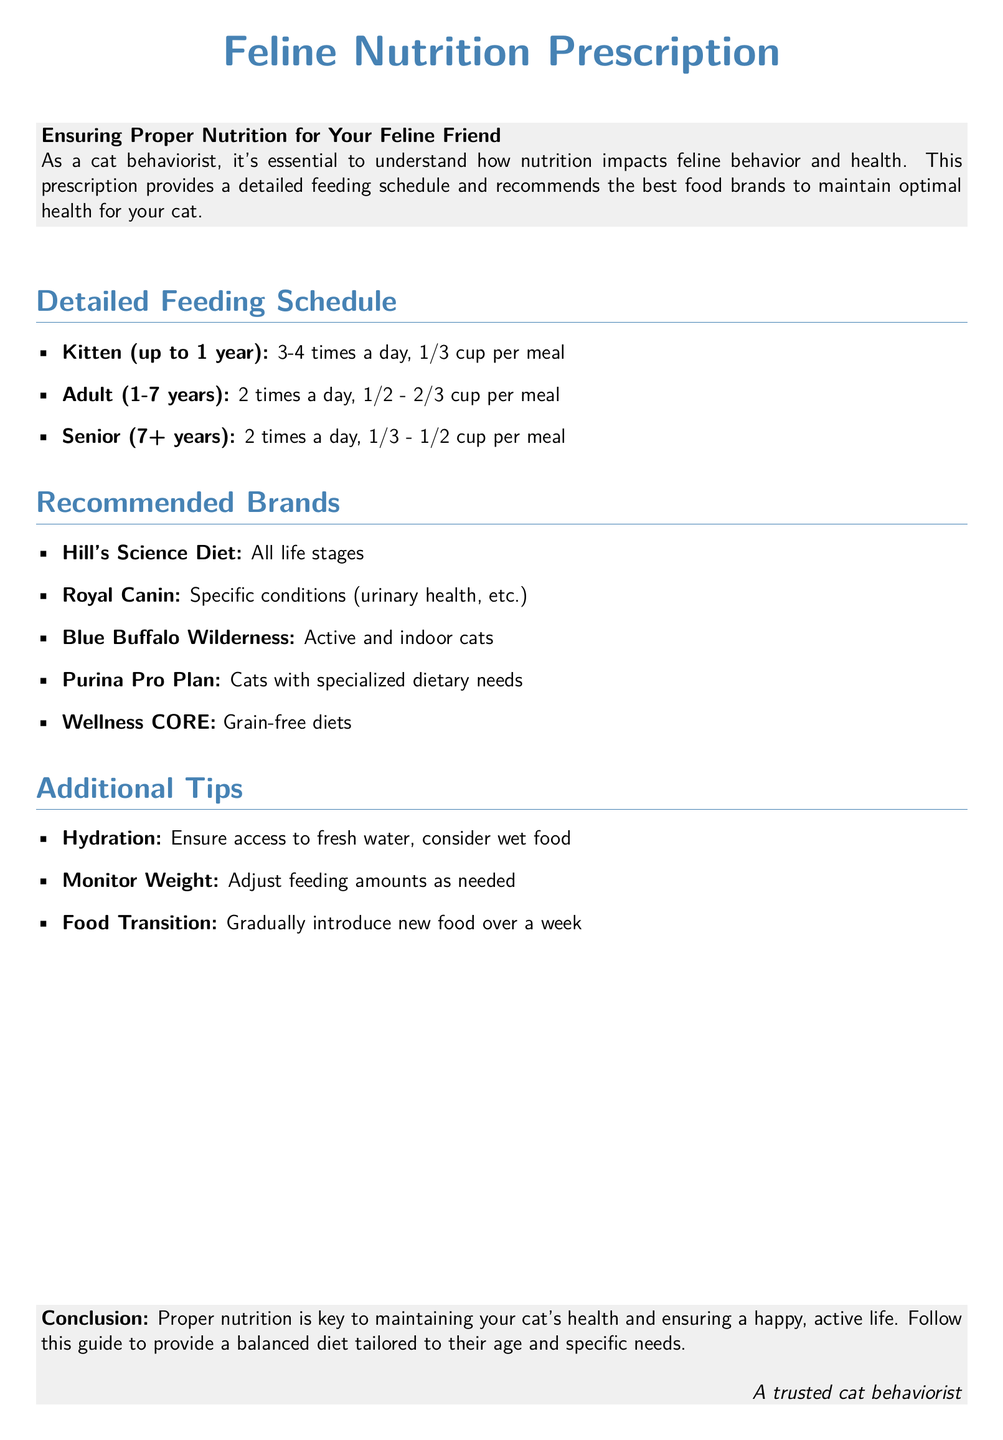What is the feeding frequency for kittens? The document states that kittens should be fed 3-4 times a day.
Answer: 3-4 times a day How much food should an adult cat receive per meal? The document specifies that adult cats should receive 1/2 - 2/3 cup per meal.
Answer: 1/2 - 2/3 cup Which brand is recommended for urinary health? The document highlights Royal Canin as the brand for specific conditions like urinary health.
Answer: Royal Canin What age qualifies a cat as senior? The document mentions that a cat 7 years and older is considered senior.
Answer: 7+ years What should you ensure access to for hydration? According to the document, fresh water should be available for hydration.
Answer: Fresh water What is an important consideration when transitioning food? The document advises that new food should be introduced gradually over a week.
Answer: Gradually over a week How many times a day should a senior cat be fed? The document states that senior cats should be fed 2 times a day.
Answer: 2 times a day Which recommended brand is known for grain-free diets? The document lists Wellness CORE as the brand for grain-free diets.
Answer: Wellness CORE 